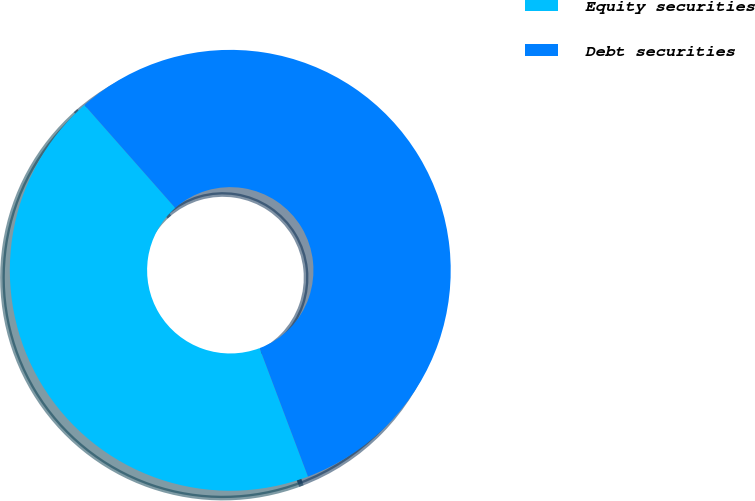<chart> <loc_0><loc_0><loc_500><loc_500><pie_chart><fcel>Equity securities<fcel>Debt securities<nl><fcel>44.23%<fcel>55.77%<nl></chart> 